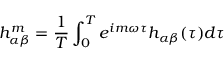Convert formula to latex. <formula><loc_0><loc_0><loc_500><loc_500>h _ { \alpha \beta } ^ { m } = \frac { 1 } { T } \int _ { 0 } ^ { T } e ^ { i m \omega \tau } h _ { \alpha \beta } ( \tau ) d \tau</formula> 